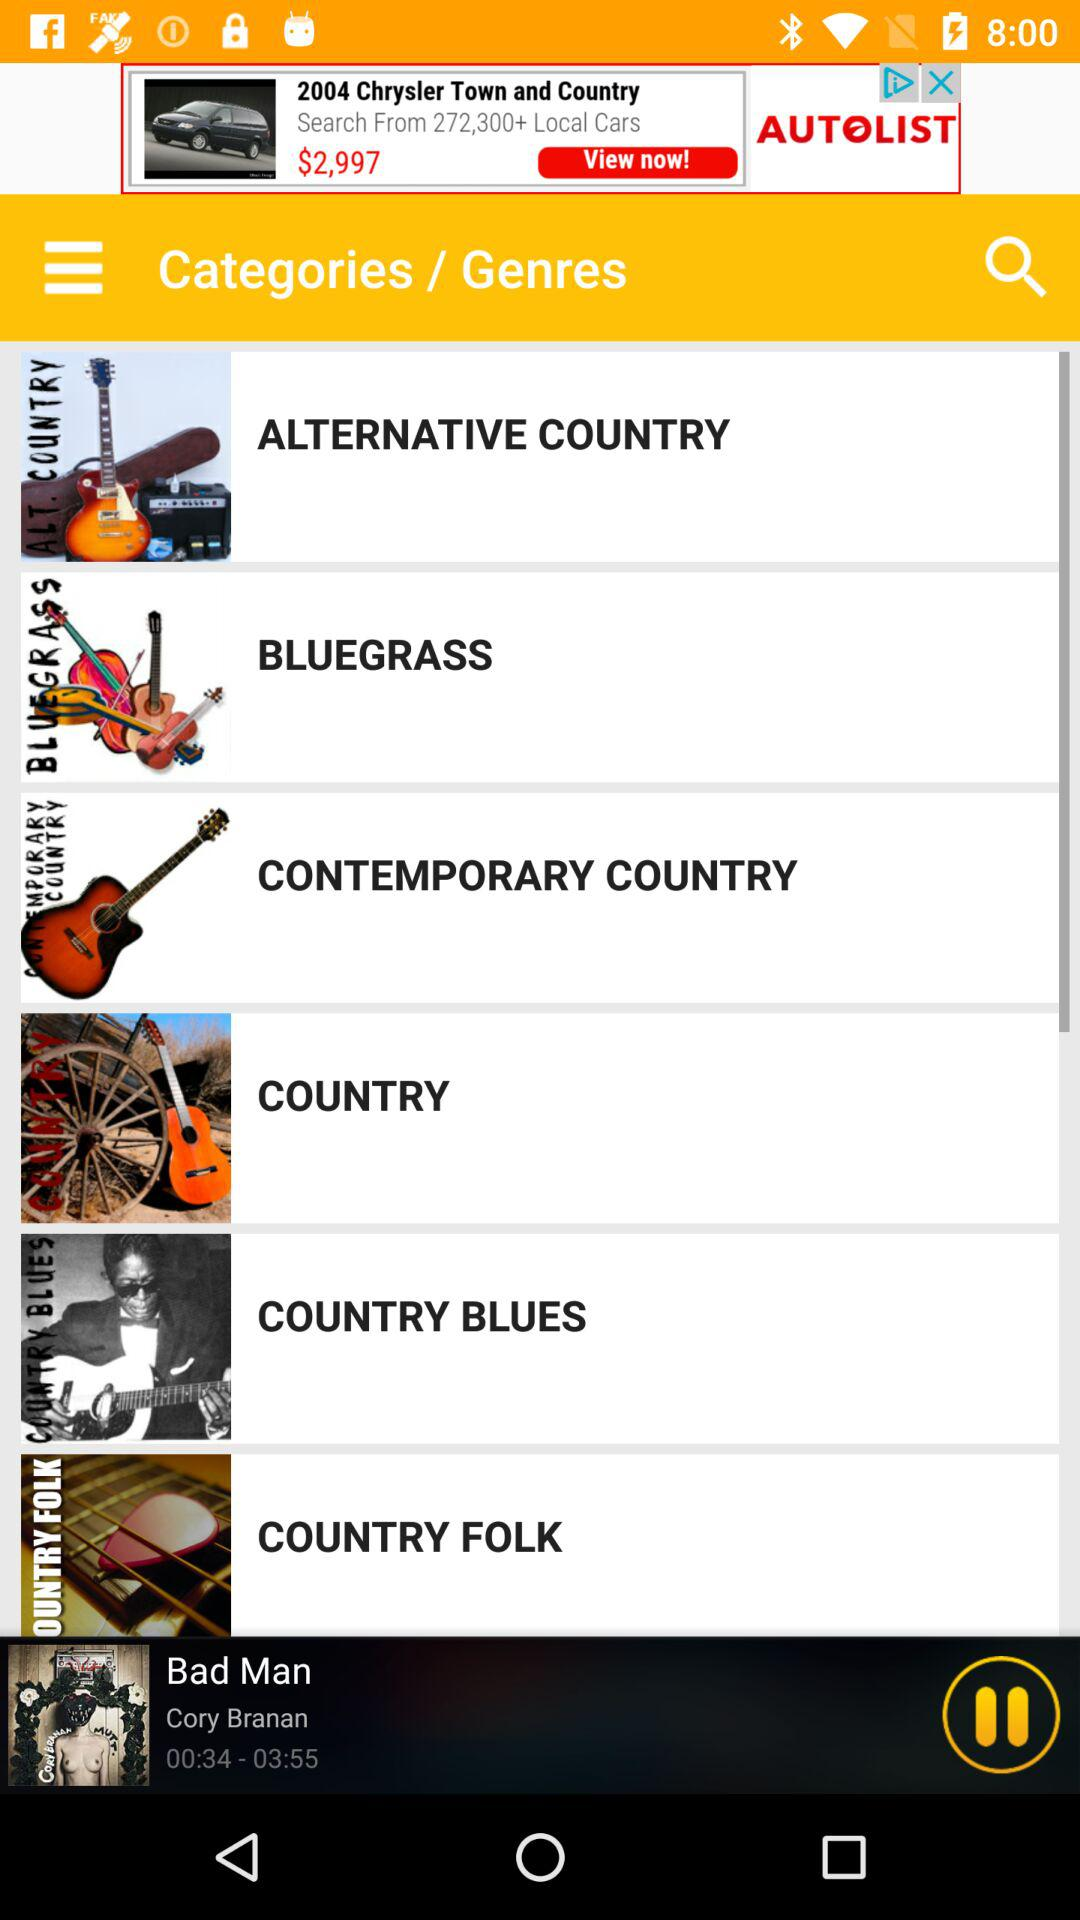What is the time duration of the song "Bad Man"? The time duration of the song "Bad Man" is 3 minutes 55 seconds. 